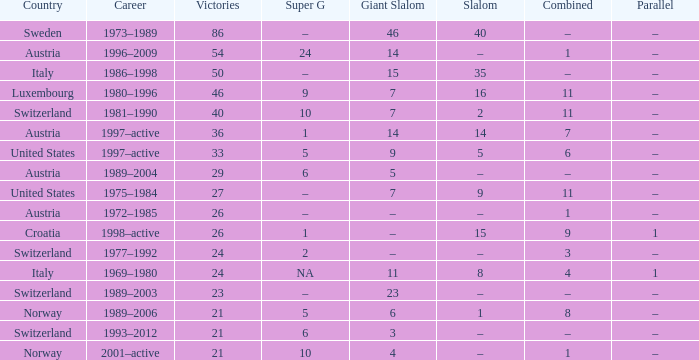What job has a parallel of –, an integrated of –, and a giant slalom of 5? 1989–2004. Would you be able to parse every entry in this table? {'header': ['Country', 'Career', 'Victories', 'Super G', 'Giant Slalom', 'Slalom', 'Combined', 'Parallel'], 'rows': [['Sweden', '1973–1989', '86', '–', '46', '40', '–', '–'], ['Austria', '1996–2009', '54', '24', '14', '–', '1', '–'], ['Italy', '1986–1998', '50', '–', '15', '35', '–', '–'], ['Luxembourg', '1980–1996', '46', '9', '7', '16', '11', '–'], ['Switzerland', '1981–1990', '40', '10', '7', '2', '11', '–'], ['Austria', '1997–active', '36', '1', '14', '14', '7', '–'], ['United States', '1997–active', '33', '5', '9', '5', '6', '–'], ['Austria', '1989–2004', '29', '6', '5', '–', '–', '–'], ['United States', '1975–1984', '27', '–', '7', '9', '11', '–'], ['Austria', '1972–1985', '26', '–', '–', '–', '1', '–'], ['Croatia', '1998–active', '26', '1', '–', '15', '9', '1'], ['Switzerland', '1977–1992', '24', '2', '–', '–', '3', '–'], ['Italy', '1969–1980', '24', 'NA', '11', '8', '4', '1'], ['Switzerland', '1989–2003', '23', '–', '23', '–', '–', '–'], ['Norway', '1989–2006', '21', '5', '6', '1', '8', '–'], ['Switzerland', '1993–2012', '21', '6', '3', '–', '–', '–'], ['Norway', '2001–active', '21', '10', '4', '–', '1', '–']]} 